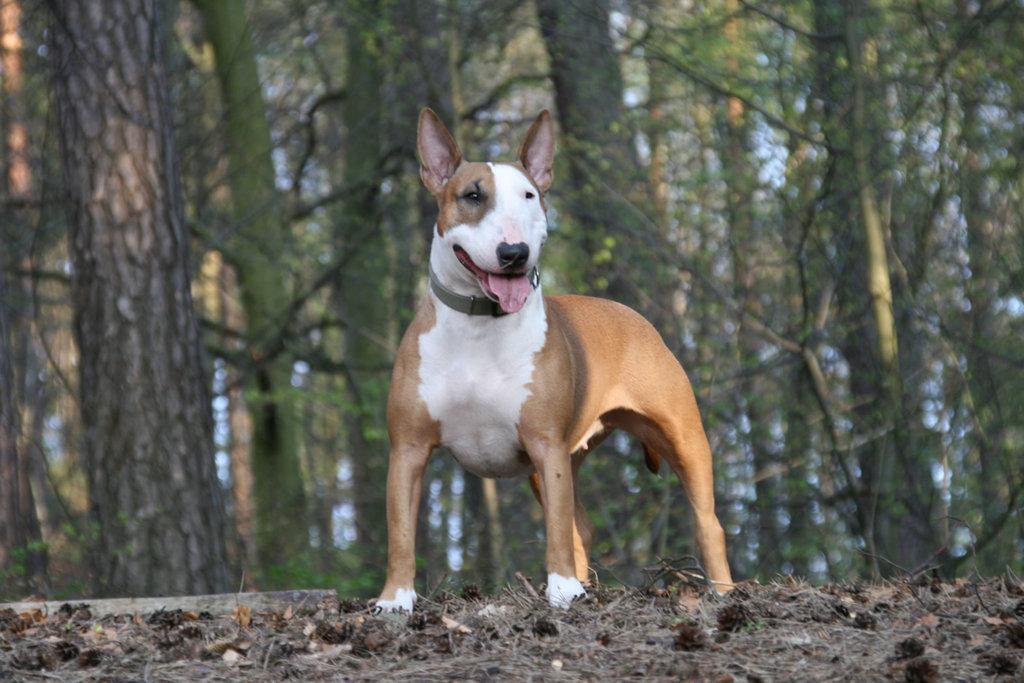How would you summarize this image in a sentence or two? In this image in the center there is one dog and in the background there are some trees, at the bottom there is some scrap. 